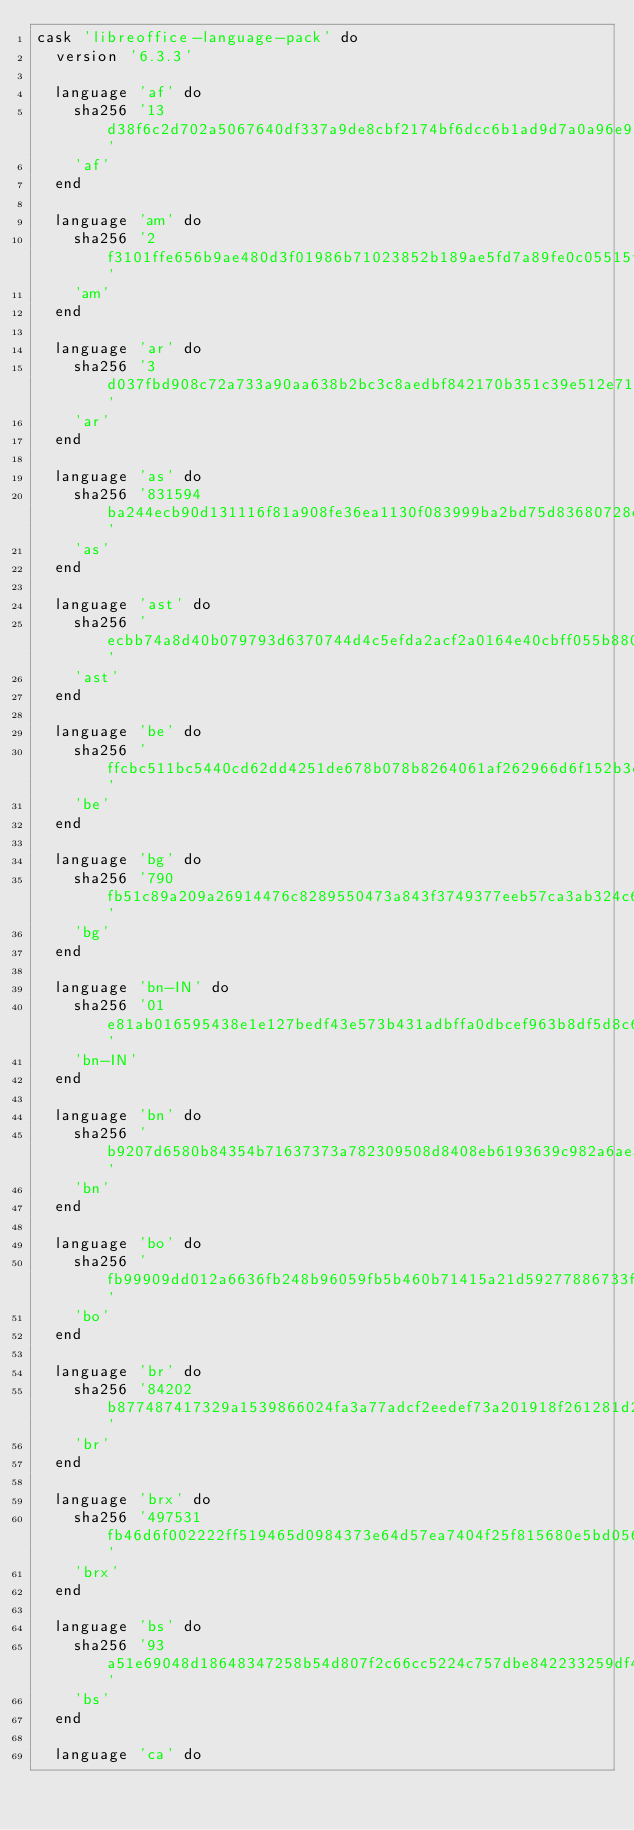Convert code to text. <code><loc_0><loc_0><loc_500><loc_500><_Ruby_>cask 'libreoffice-language-pack' do
  version '6.3.3'

  language 'af' do
    sha256 '13d38f6c2d702a5067640df337a9de8cbf2174bf6dcc6b1ad9d7a0a96e921af4'
    'af'
  end

  language 'am' do
    sha256 '2f3101ffe656b9ae480d3f01986b71023852b189ae5fd7a89fe0c05515f099a3'
    'am'
  end

  language 'ar' do
    sha256 '3d037fbd908c72a733a90aa638b2bc3c8aedbf842170b351c39e512e7129cf36'
    'ar'
  end

  language 'as' do
    sha256 '831594ba244ecb90d131116f81a908fe36ea1130f083999ba2bd75d83680728c'
    'as'
  end

  language 'ast' do
    sha256 'ecbb74a8d40b079793d6370744d4c5efda2acf2a0164e40cbff055b880833dc0'
    'ast'
  end

  language 'be' do
    sha256 'ffcbc511bc5440cd62dd4251de678b078b8264061af262966d6f152b3d921f63'
    'be'
  end

  language 'bg' do
    sha256 '790fb51c89a209a26914476c8289550473a843f3749377eeb57ca3ab324c694d'
    'bg'
  end

  language 'bn-IN' do
    sha256 '01e81ab016595438e1e127bedf43e573b431adbffa0dbcef963b8df5d8c6674c'
    'bn-IN'
  end

  language 'bn' do
    sha256 'b9207d6580b84354b71637373a782309508d8408eb6193639c982a6ae370e1e3'
    'bn'
  end

  language 'bo' do
    sha256 'fb99909dd012a6636fb248b96059fb5b460b71415a21d59277886733fc703fdf'
    'bo'
  end

  language 'br' do
    sha256 '84202b877487417329a1539866024fa3a77adcf2eedef73a201918f261281d23'
    'br'
  end

  language 'brx' do
    sha256 '497531fb46d6f002222ff519465d0984373e64d57ea7404f25f815680e5bd056'
    'brx'
  end

  language 'bs' do
    sha256 '93a51e69048d18648347258b54d807f2c66cc5224c757dbe842233259df49083'
    'bs'
  end

  language 'ca' do</code> 